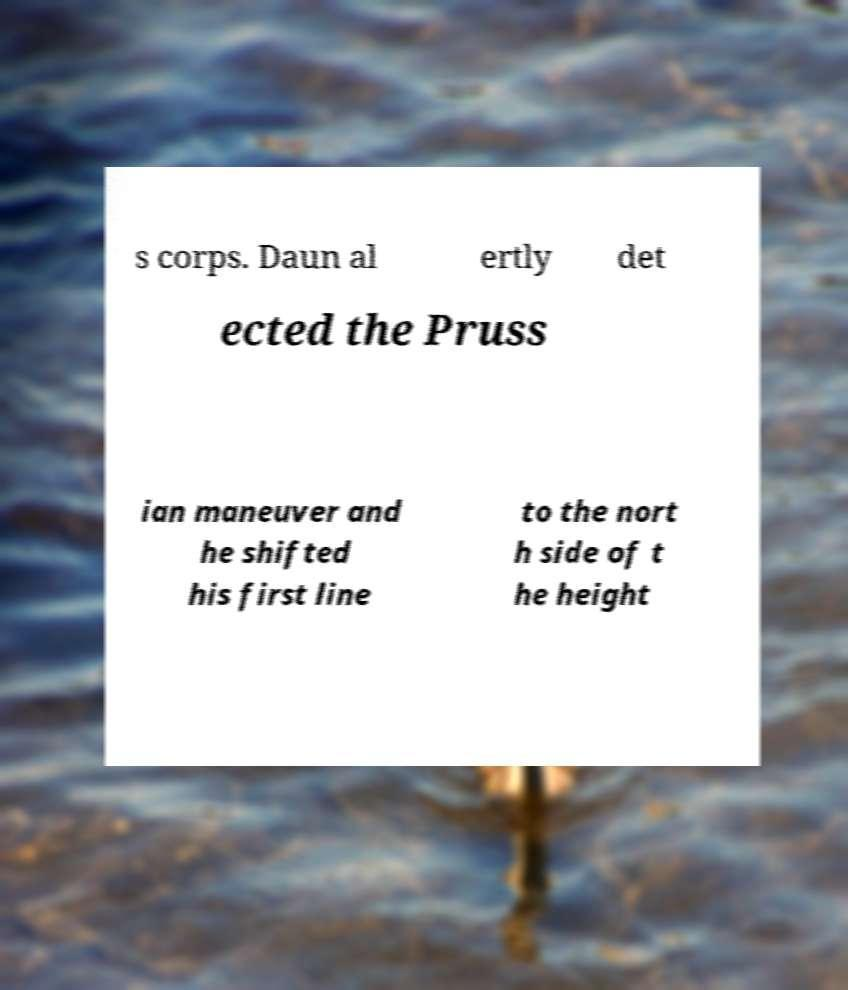I need the written content from this picture converted into text. Can you do that? s corps. Daun al ertly det ected the Pruss ian maneuver and he shifted his first line to the nort h side of t he height 